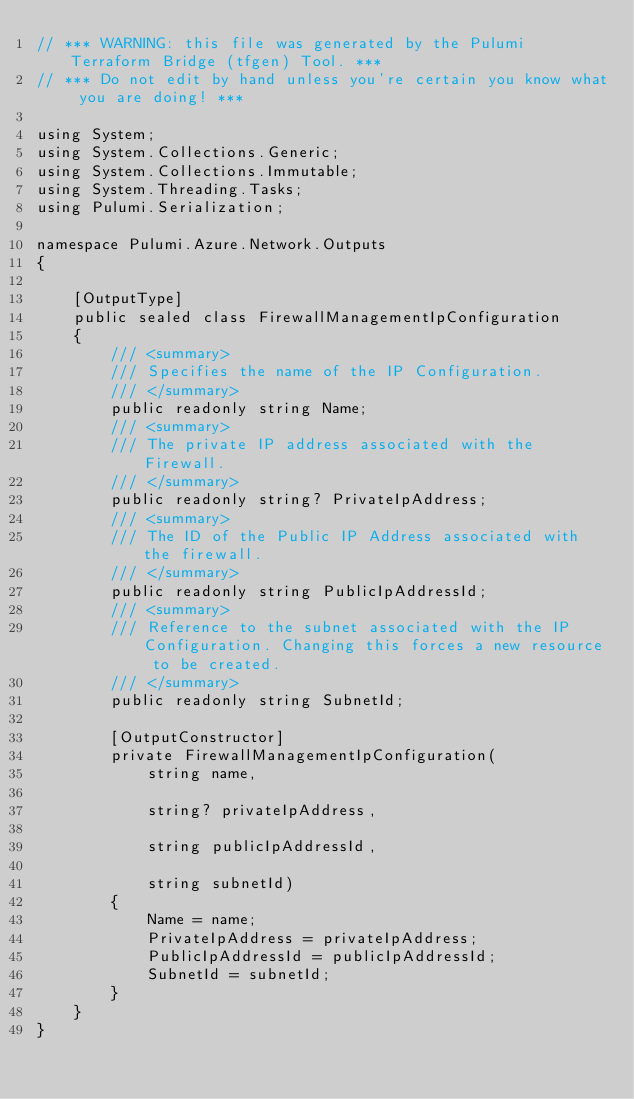<code> <loc_0><loc_0><loc_500><loc_500><_C#_>// *** WARNING: this file was generated by the Pulumi Terraform Bridge (tfgen) Tool. ***
// *** Do not edit by hand unless you're certain you know what you are doing! ***

using System;
using System.Collections.Generic;
using System.Collections.Immutable;
using System.Threading.Tasks;
using Pulumi.Serialization;

namespace Pulumi.Azure.Network.Outputs
{

    [OutputType]
    public sealed class FirewallManagementIpConfiguration
    {
        /// <summary>
        /// Specifies the name of the IP Configuration.
        /// </summary>
        public readonly string Name;
        /// <summary>
        /// The private IP address associated with the Firewall.
        /// </summary>
        public readonly string? PrivateIpAddress;
        /// <summary>
        /// The ID of the Public IP Address associated with the firewall.
        /// </summary>
        public readonly string PublicIpAddressId;
        /// <summary>
        /// Reference to the subnet associated with the IP Configuration. Changing this forces a new resource to be created.
        /// </summary>
        public readonly string SubnetId;

        [OutputConstructor]
        private FirewallManagementIpConfiguration(
            string name,

            string? privateIpAddress,

            string publicIpAddressId,

            string subnetId)
        {
            Name = name;
            PrivateIpAddress = privateIpAddress;
            PublicIpAddressId = publicIpAddressId;
            SubnetId = subnetId;
        }
    }
}
</code> 